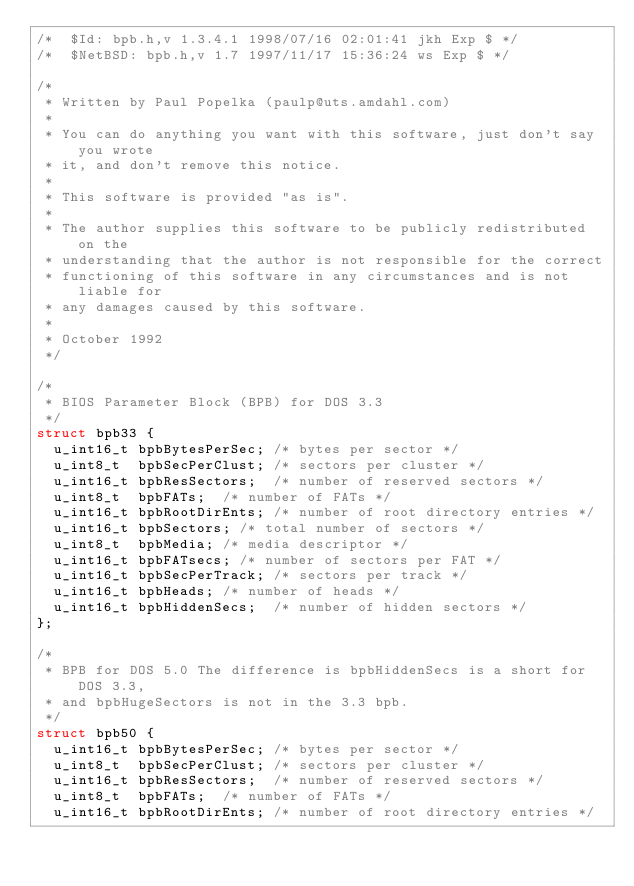<code> <loc_0><loc_0><loc_500><loc_500><_C_>/*	$Id: bpb.h,v 1.3.4.1 1998/07/16 02:01:41 jkh Exp $ */
/*	$NetBSD: bpb.h,v 1.7 1997/11/17 15:36:24 ws Exp $	*/

/*
 * Written by Paul Popelka (paulp@uts.amdahl.com)
 *
 * You can do anything you want with this software, just don't say you wrote
 * it, and don't remove this notice.
 *
 * This software is provided "as is".
 *
 * The author supplies this software to be publicly redistributed on the
 * understanding that the author is not responsible for the correct
 * functioning of this software in any circumstances and is not liable for
 * any damages caused by this software.
 *
 * October 1992
 */

/*
 * BIOS Parameter Block (BPB) for DOS 3.3
 */
struct bpb33 {
	u_int16_t	bpbBytesPerSec;	/* bytes per sector */
	u_int8_t	bpbSecPerClust;	/* sectors per cluster */
	u_int16_t	bpbResSectors;	/* number of reserved sectors */
	u_int8_t	bpbFATs;	/* number of FATs */
	u_int16_t	bpbRootDirEnts;	/* number of root directory entries */
	u_int16_t	bpbSectors;	/* total number of sectors */
	u_int8_t	bpbMedia;	/* media descriptor */
	u_int16_t	bpbFATsecs;	/* number of sectors per FAT */
	u_int16_t	bpbSecPerTrack;	/* sectors per track */
	u_int16_t	bpbHeads;	/* number of heads */
	u_int16_t	bpbHiddenSecs;	/* number of hidden sectors */
};

/*
 * BPB for DOS 5.0 The difference is bpbHiddenSecs is a short for DOS 3.3,
 * and bpbHugeSectors is not in the 3.3 bpb.
 */
struct bpb50 {
	u_int16_t	bpbBytesPerSec;	/* bytes per sector */
	u_int8_t	bpbSecPerClust;	/* sectors per cluster */
	u_int16_t	bpbResSectors;	/* number of reserved sectors */
	u_int8_t	bpbFATs;	/* number of FATs */
	u_int16_t	bpbRootDirEnts;	/* number of root directory entries */</code> 